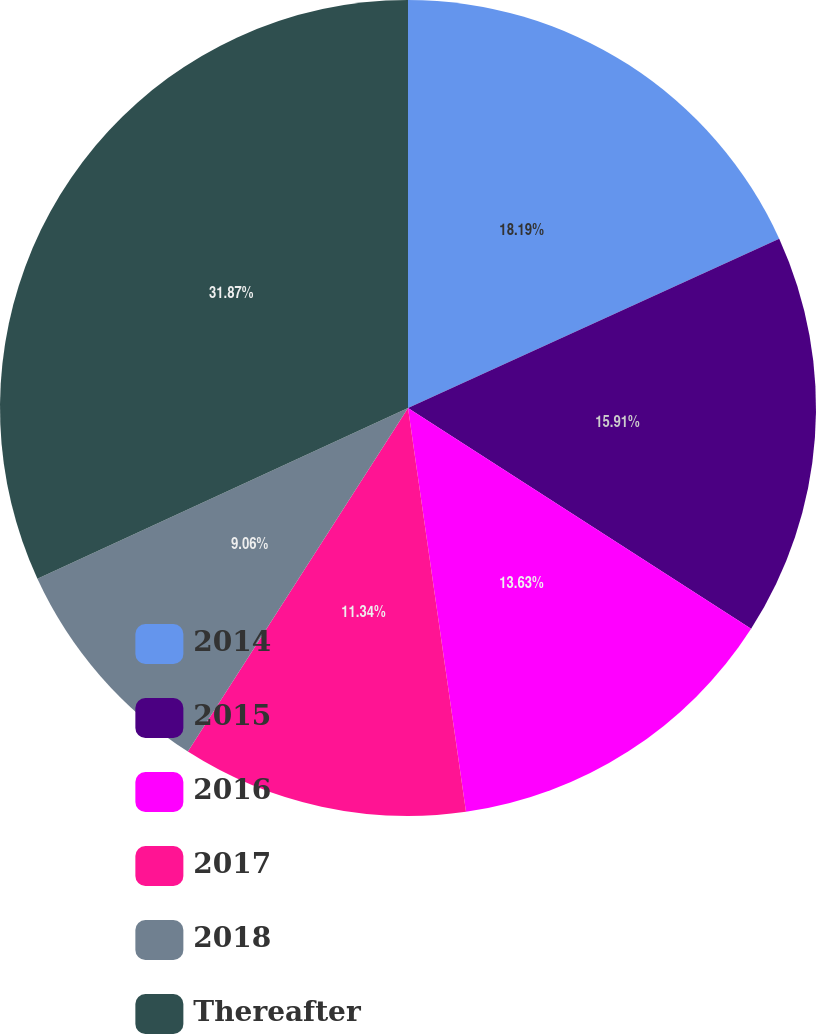Convert chart. <chart><loc_0><loc_0><loc_500><loc_500><pie_chart><fcel>2014<fcel>2015<fcel>2016<fcel>2017<fcel>2018<fcel>Thereafter<nl><fcel>18.19%<fcel>15.91%<fcel>13.63%<fcel>11.34%<fcel>9.06%<fcel>31.87%<nl></chart> 